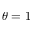<formula> <loc_0><loc_0><loc_500><loc_500>\theta = 1</formula> 